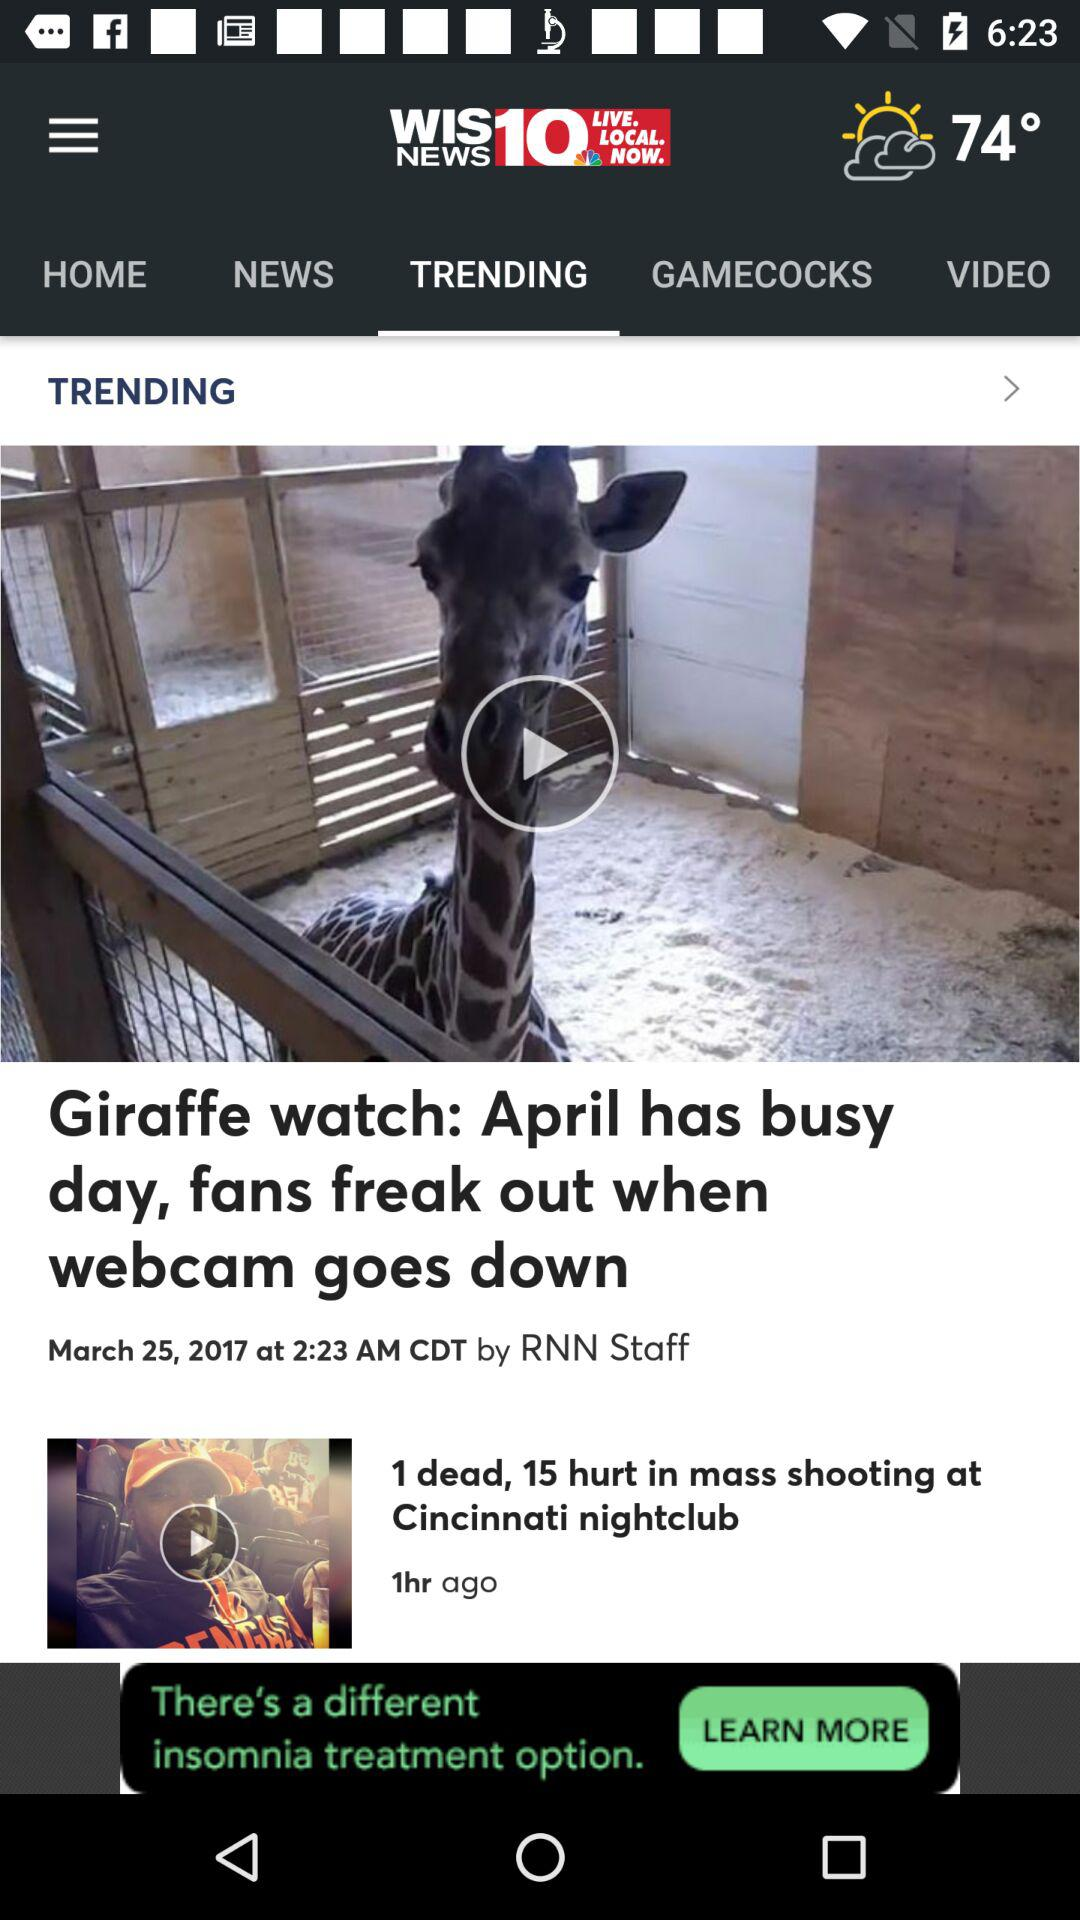What is the date of the news "Giraffe watch: April has busy day, fans freak out when webcam goes down"? The date of the news is March 25, 2017. 